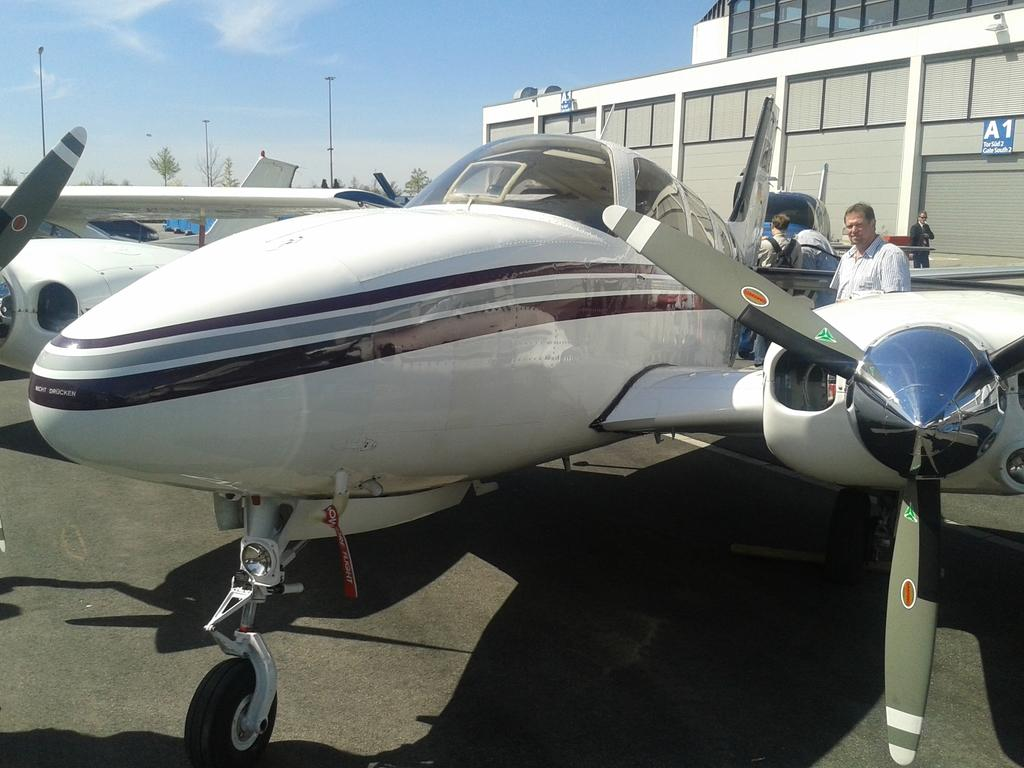What type of vehicles are on the ground in the image? There are small airplanes on the ground in the image. What are the people in the image doing? The people in the image are looking at the airplanes. What color is the sky in the image? The sky is blue in the image. What type of vessel is being used for swimming in the image? There is no vessel or swimming activity present in the image. 